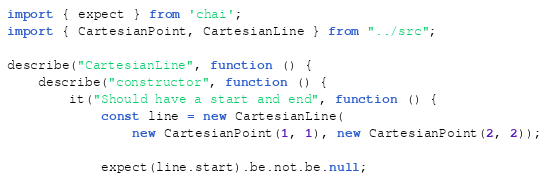<code> <loc_0><loc_0><loc_500><loc_500><_TypeScript_>import { expect } from 'chai';
import { CartesianPoint, CartesianLine } from "../src";

describe("CartesianLine", function () {
    describe("constructor", function () {
        it("Should have a start and end", function () {
            const line = new CartesianLine(
                new CartesianPoint(1, 1), new CartesianPoint(2, 2));

            expect(line.start).be.not.be.null;</code> 